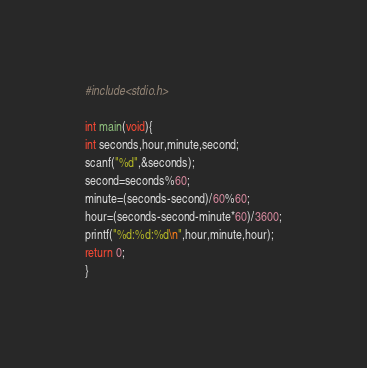Convert code to text. <code><loc_0><loc_0><loc_500><loc_500><_C_>#include<stdio.h>

int main(void){
int seconds,hour,minute,second;
scanf("%d",&seconds);
second=seconds%60;
minute=(seconds-second)/60%60;
hour=(seconds-second-minute*60)/3600;
printf("%d:%d:%d\n",hour,minute,hour);
return 0;
}</code> 